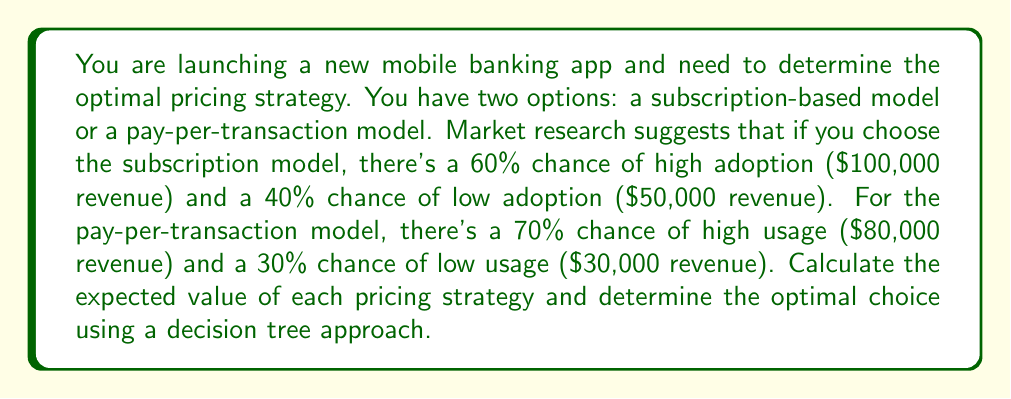Provide a solution to this math problem. To solve this problem, we'll use a decision tree approach and calculate the expected value for each pricing strategy.

1. Subscription-based model:
   - High adoption (60%): $100,000
   - Low adoption (40%): $50,000
   
   Expected Value (EV) of subscription model:
   $$EV_{subscription} = 0.60 \times \$100,000 + 0.40 \times \$50,000$$
   $$EV_{subscription} = \$60,000 + \$20,000 = \$80,000$$

2. Pay-per-transaction model:
   - High usage (70%): $80,000
   - Low usage (30%): $30,000
   
   Expected Value (EV) of pay-per-transaction model:
   $$EV_{pay-per-transaction} = 0.70 \times \$80,000 + 0.30 \times \$30,000$$
   $$EV_{pay-per-transaction} = \$56,000 + \$9,000 = \$65,000$$

Decision tree representation:
[asy]
import geometry;

pair A=(0,0), B=(100,50), C=(100,-50);
pair D=(200,75), E=(200,25), F=(200,-25), G=(200,-75);

draw(A--B--D);
draw(B--E);
draw(A--C--F);
draw(C--G);

label("Start", A, W);
label("Subscription", B, E);
label("Pay-per-transaction", C, E);
label("High (60%): $100k", D, E);
label("Low (40%): $50k", E, E);
label("High (70%): $80k", F, E);
label("Low (30%): $30k", G, E);

label("EV: $80k", (150,50), E);
label("EV: $65k", (150,-50), E);

dot(A);
dot(B);
dot(C);
dot(D);
dot(E);
dot(F);
dot(G);
[/asy]

To determine the optimal pricing strategy, we compare the expected values:

$$EV_{subscription} = \$80,000 > EV_{pay-per-transaction} = \$65,000$$

Therefore, the subscription-based model has a higher expected value and is the optimal pricing strategy for the new mobile banking app.
Answer: The optimal pricing strategy is the subscription-based model, with an expected value of $80,000, compared to $65,000 for the pay-per-transaction model. 